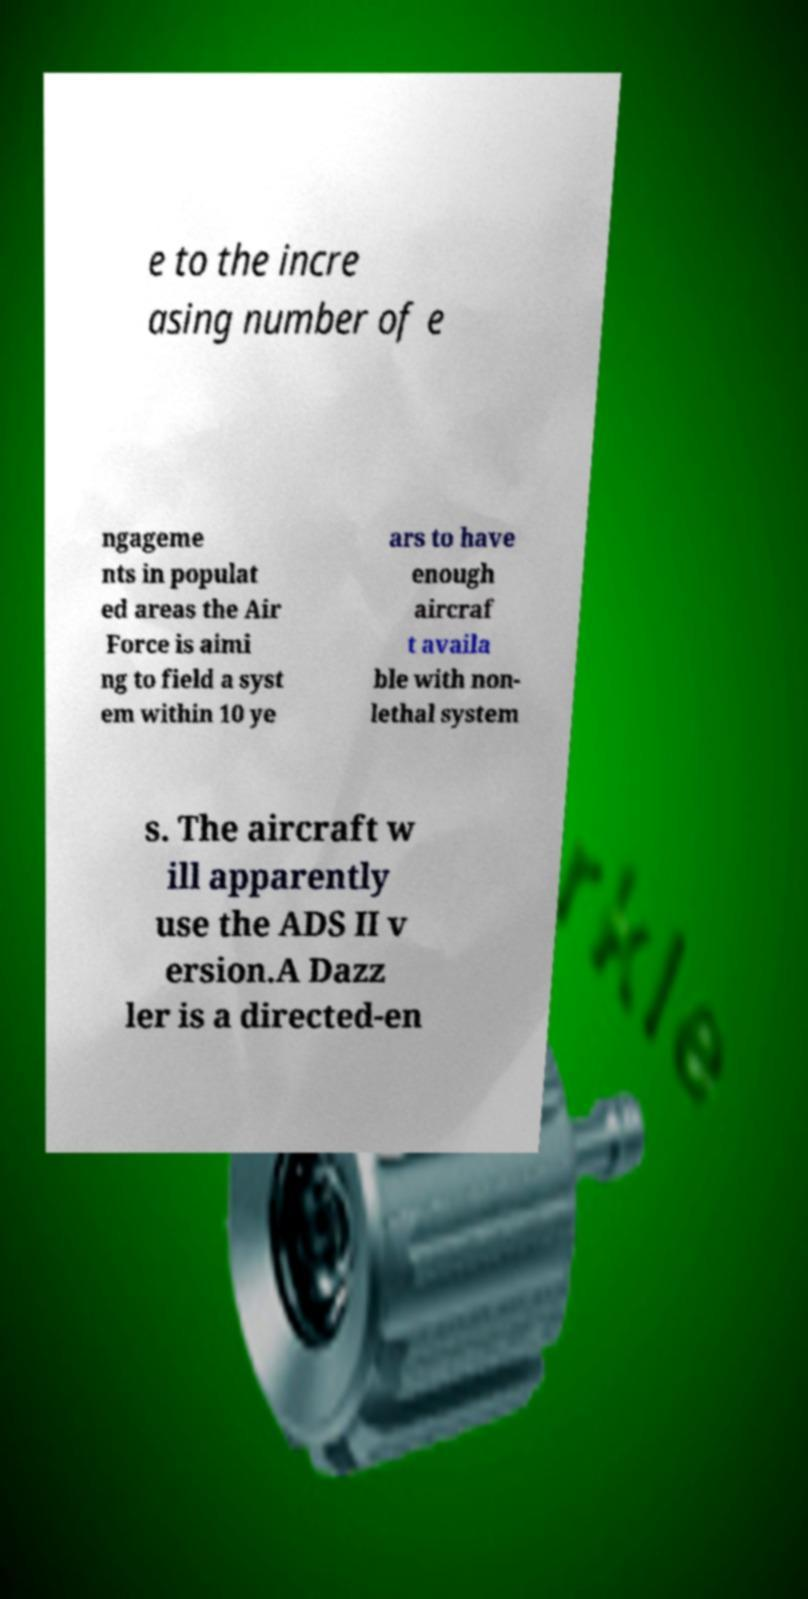I need the written content from this picture converted into text. Can you do that? e to the incre asing number of e ngageme nts in populat ed areas the Air Force is aimi ng to field a syst em within 10 ye ars to have enough aircraf t availa ble with non- lethal system s. The aircraft w ill apparently use the ADS II v ersion.A Dazz ler is a directed-en 